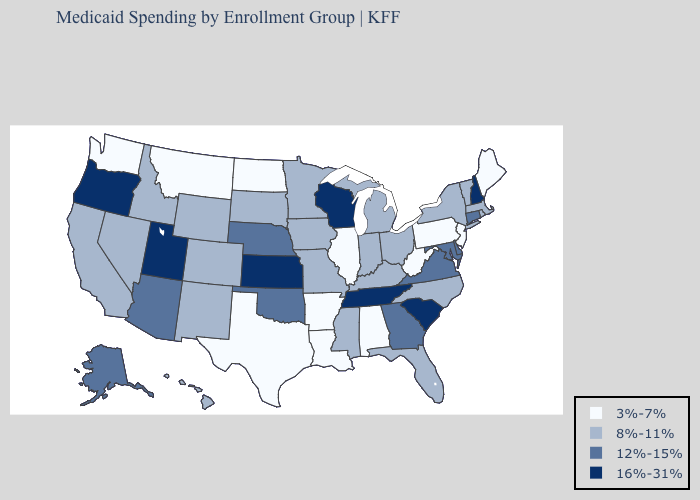What is the value of Texas?
Concise answer only. 3%-7%. What is the lowest value in the Northeast?
Keep it brief. 3%-7%. What is the value of Arkansas?
Quick response, please. 3%-7%. Does Alaska have the highest value in the USA?
Keep it brief. No. Name the states that have a value in the range 3%-7%?
Concise answer only. Alabama, Arkansas, Illinois, Louisiana, Maine, Montana, New Jersey, North Dakota, Pennsylvania, Texas, Washington, West Virginia. Does the first symbol in the legend represent the smallest category?
Keep it brief. Yes. What is the value of Minnesota?
Short answer required. 8%-11%. What is the value of Idaho?
Give a very brief answer. 8%-11%. What is the highest value in the USA?
Write a very short answer. 16%-31%. Does Kansas have the highest value in the USA?
Answer briefly. Yes. What is the value of Kansas?
Be succinct. 16%-31%. Which states have the lowest value in the USA?
Write a very short answer. Alabama, Arkansas, Illinois, Louisiana, Maine, Montana, New Jersey, North Dakota, Pennsylvania, Texas, Washington, West Virginia. Does the map have missing data?
Keep it brief. No. Does New Mexico have the lowest value in the West?
Answer briefly. No. Name the states that have a value in the range 8%-11%?
Concise answer only. California, Colorado, Florida, Hawaii, Idaho, Indiana, Iowa, Kentucky, Massachusetts, Michigan, Minnesota, Mississippi, Missouri, Nevada, New Mexico, New York, North Carolina, Ohio, Rhode Island, South Dakota, Vermont, Wyoming. 